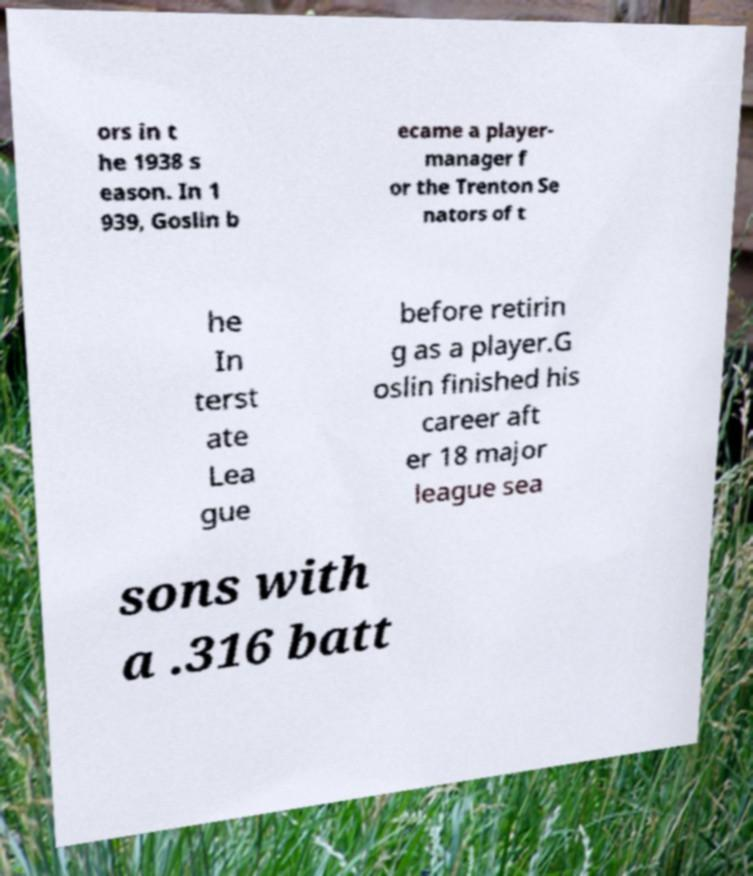There's text embedded in this image that I need extracted. Can you transcribe it verbatim? ors in t he 1938 s eason. In 1 939, Goslin b ecame a player- manager f or the Trenton Se nators of t he In terst ate Lea gue before retirin g as a player.G oslin finished his career aft er 18 major league sea sons with a .316 batt 